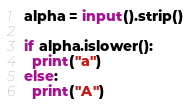<code> <loc_0><loc_0><loc_500><loc_500><_Python_>alpha = input().strip()

if alpha.islower():
  print("a")
else:
  print("A")</code> 